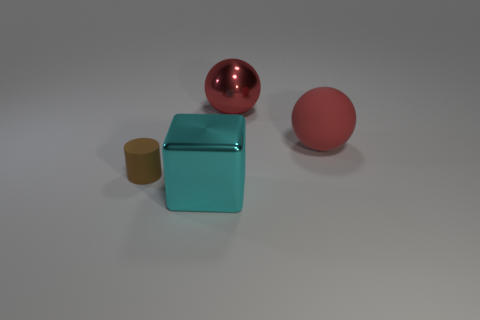What materials do the objects appear to be made from? From their appearance, it seems that the objects are made from different materials. The red sphere has a reflective surface that suggests it might be made out of metal, possibly painted steel or anodized aluminum. The teal cube also has a metallic sheen, indicative of a material like painted metal. Lastly, the small brown cylinder has a matte surface which could imply it's made of a non-metallic material, such as ceramic or plastic. 